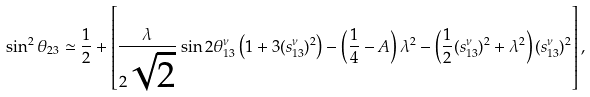Convert formula to latex. <formula><loc_0><loc_0><loc_500><loc_500>\sin ^ { 2 } \theta _ { 2 3 } \simeq \frac { 1 } { 2 } + \left [ \frac { \lambda } { 2 \sqrt { 2 } } \sin 2 \theta ^ { \nu } _ { 1 3 } \left ( 1 + 3 ( s ^ { \nu } _ { 1 3 } ) ^ { 2 } \right ) - \left ( \frac { 1 } { 4 } - A \right ) \lambda ^ { 2 } - \left ( \frac { 1 } { 2 } ( s ^ { \nu } _ { 1 3 } ) ^ { 2 } + \lambda ^ { 2 } \right ) ( s ^ { \nu } _ { 1 3 } ) ^ { 2 } \right ] ,</formula> 